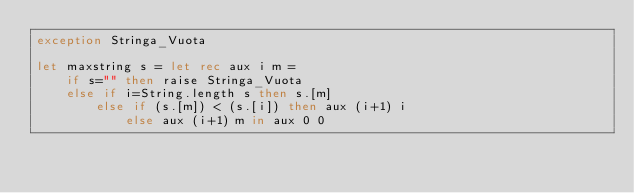<code> <loc_0><loc_0><loc_500><loc_500><_OCaml_>exception Stringa_Vuota

let maxstring s = let rec aux i m = 
	if s="" then raise Stringa_Vuota
  	else if i=String.length s then s.[m] 
  		else if (s.[m]) < (s.[i]) then aux (i+1) i 
  			else aux (i+1) m in aux 0 0</code> 